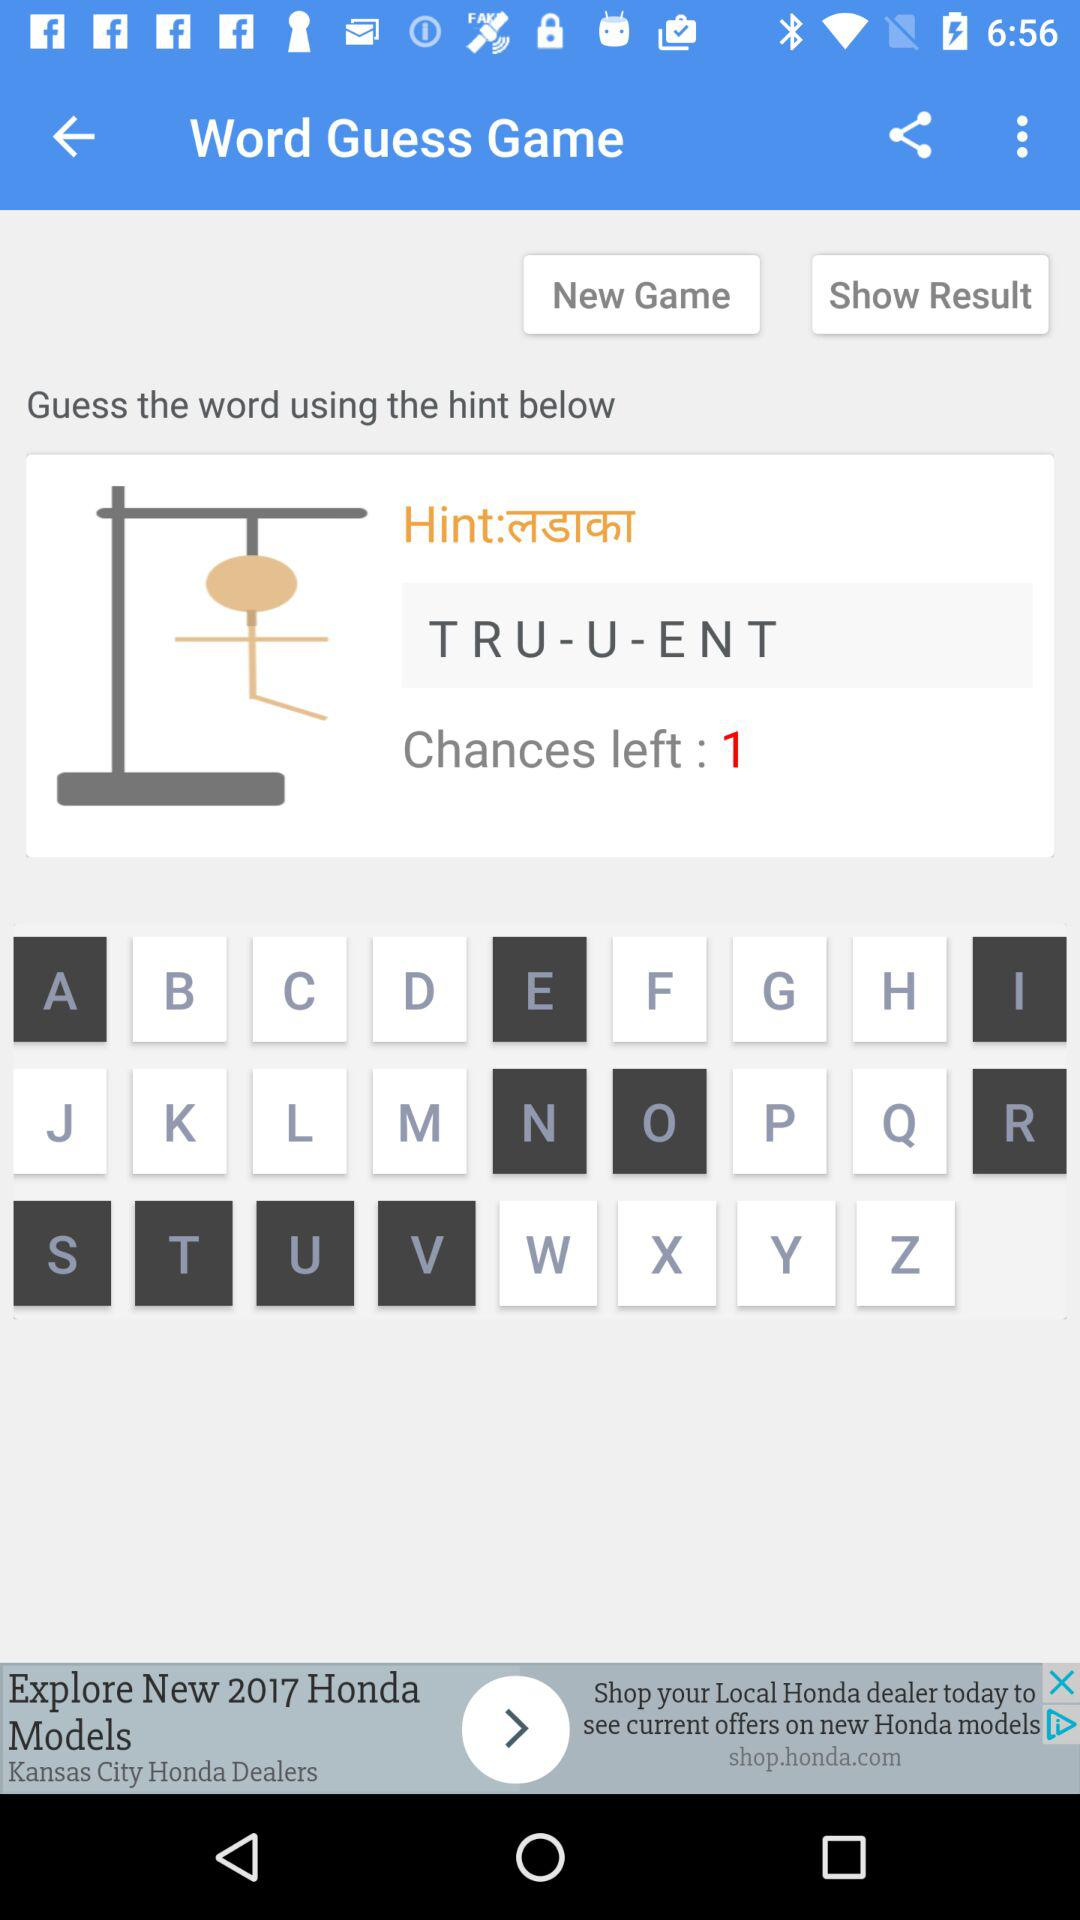How many chances do I have left?
Answer the question using a single word or phrase. 1 